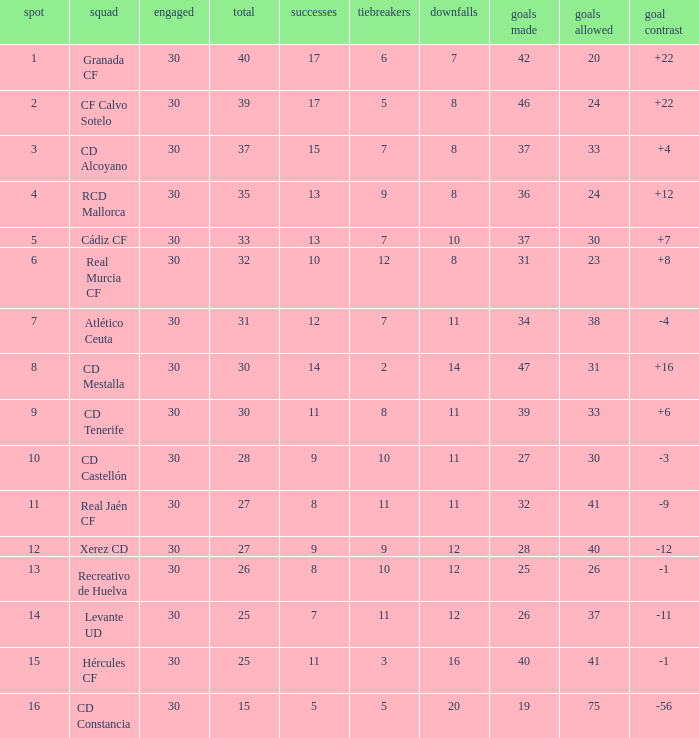Parse the full table. {'header': ['spot', 'squad', 'engaged', 'total', 'successes', 'tiebreakers', 'downfalls', 'goals made', 'goals allowed', 'goal contrast'], 'rows': [['1', 'Granada CF', '30', '40', '17', '6', '7', '42', '20', '+22'], ['2', 'CF Calvo Sotelo', '30', '39', '17', '5', '8', '46', '24', '+22'], ['3', 'CD Alcoyano', '30', '37', '15', '7', '8', '37', '33', '+4'], ['4', 'RCD Mallorca', '30', '35', '13', '9', '8', '36', '24', '+12'], ['5', 'Cádiz CF', '30', '33', '13', '7', '10', '37', '30', '+7'], ['6', 'Real Murcia CF', '30', '32', '10', '12', '8', '31', '23', '+8'], ['7', 'Atlético Ceuta', '30', '31', '12', '7', '11', '34', '38', '-4'], ['8', 'CD Mestalla', '30', '30', '14', '2', '14', '47', '31', '+16'], ['9', 'CD Tenerife', '30', '30', '11', '8', '11', '39', '33', '+6'], ['10', 'CD Castellón', '30', '28', '9', '10', '11', '27', '30', '-3'], ['11', 'Real Jaén CF', '30', '27', '8', '11', '11', '32', '41', '-9'], ['12', 'Xerez CD', '30', '27', '9', '9', '12', '28', '40', '-12'], ['13', 'Recreativo de Huelva', '30', '26', '8', '10', '12', '25', '26', '-1'], ['14', 'Levante UD', '30', '25', '7', '11', '12', '26', '37', '-11'], ['15', 'Hércules CF', '30', '25', '11', '3', '16', '40', '41', '-1'], ['16', 'CD Constancia', '30', '15', '5', '5', '20', '19', '75', '-56']]} Which Played has a Club of atlético ceuta, and less than 11 Losses? None. 